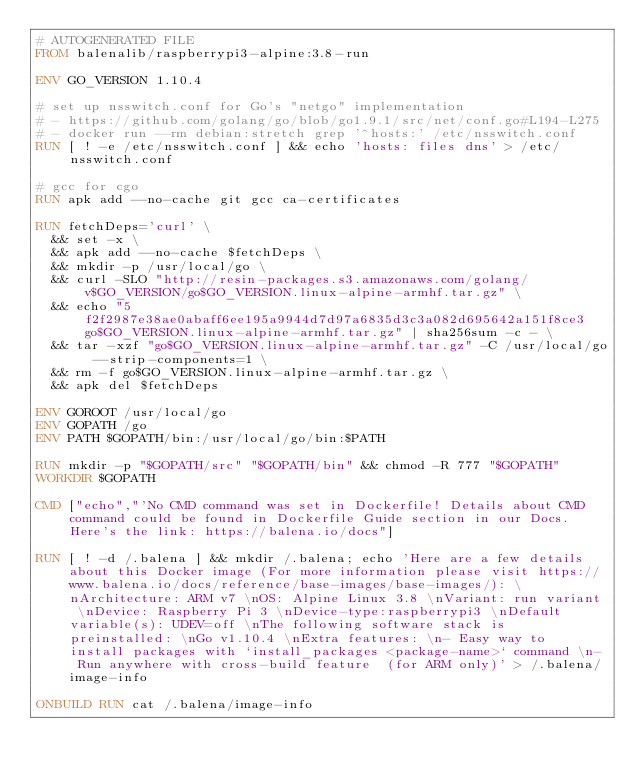Convert code to text. <code><loc_0><loc_0><loc_500><loc_500><_Dockerfile_># AUTOGENERATED FILE
FROM balenalib/raspberrypi3-alpine:3.8-run

ENV GO_VERSION 1.10.4

# set up nsswitch.conf for Go's "netgo" implementation
# - https://github.com/golang/go/blob/go1.9.1/src/net/conf.go#L194-L275
# - docker run --rm debian:stretch grep '^hosts:' /etc/nsswitch.conf
RUN [ ! -e /etc/nsswitch.conf ] && echo 'hosts: files dns' > /etc/nsswitch.conf

# gcc for cgo
RUN apk add --no-cache git gcc ca-certificates

RUN fetchDeps='curl' \
	&& set -x \
	&& apk add --no-cache $fetchDeps \
	&& mkdir -p /usr/local/go \
	&& curl -SLO "http://resin-packages.s3.amazonaws.com/golang/v$GO_VERSION/go$GO_VERSION.linux-alpine-armhf.tar.gz" \
	&& echo "5f2f2987e38ae0abaff6ee195a9944d7d97a6835d3c3a082d695642a151f8ce3  go$GO_VERSION.linux-alpine-armhf.tar.gz" | sha256sum -c - \
	&& tar -xzf "go$GO_VERSION.linux-alpine-armhf.tar.gz" -C /usr/local/go --strip-components=1 \
	&& rm -f go$GO_VERSION.linux-alpine-armhf.tar.gz \
	&& apk del $fetchDeps

ENV GOROOT /usr/local/go
ENV GOPATH /go
ENV PATH $GOPATH/bin:/usr/local/go/bin:$PATH

RUN mkdir -p "$GOPATH/src" "$GOPATH/bin" && chmod -R 777 "$GOPATH"
WORKDIR $GOPATH

CMD ["echo","'No CMD command was set in Dockerfile! Details about CMD command could be found in Dockerfile Guide section in our Docs. Here's the link: https://balena.io/docs"]

RUN [ ! -d /.balena ] && mkdir /.balena; echo 'Here are a few details about this Docker image (For more information please visit https://www.balena.io/docs/reference/base-images/base-images/): \nArchitecture: ARM v7 \nOS: Alpine Linux 3.8 \nVariant: run variant \nDevice: Raspberry Pi 3 \nDevice-type:raspberrypi3 \nDefault variable(s): UDEV=off \nThe following software stack is preinstalled: \nGo v1.10.4 \nExtra features: \n- Easy way to install packages with `install_packages <package-name>` command \n- Run anywhere with cross-build feature  (for ARM only)' > /.balena/image-info

ONBUILD RUN cat /.balena/image-info</code> 